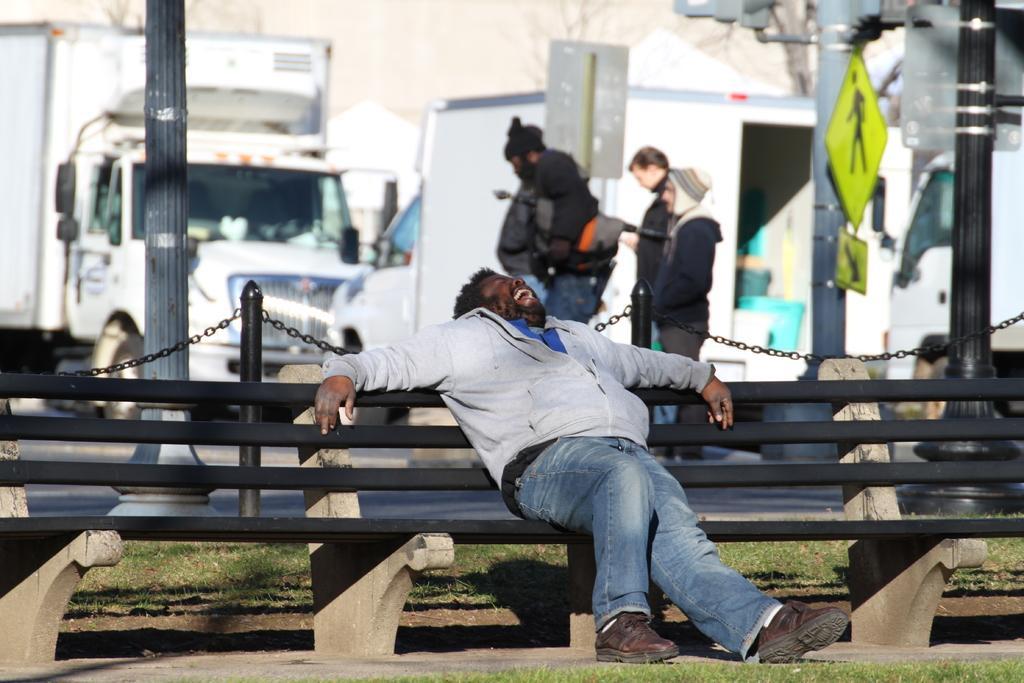Can you describe this image briefly? In this image there is a person sitting on the bench and laughing, behind him there are rods connected with the chains and there are poles and two people are walking on the road, behind them there are a few vehicles parked. In the background there are trees. 